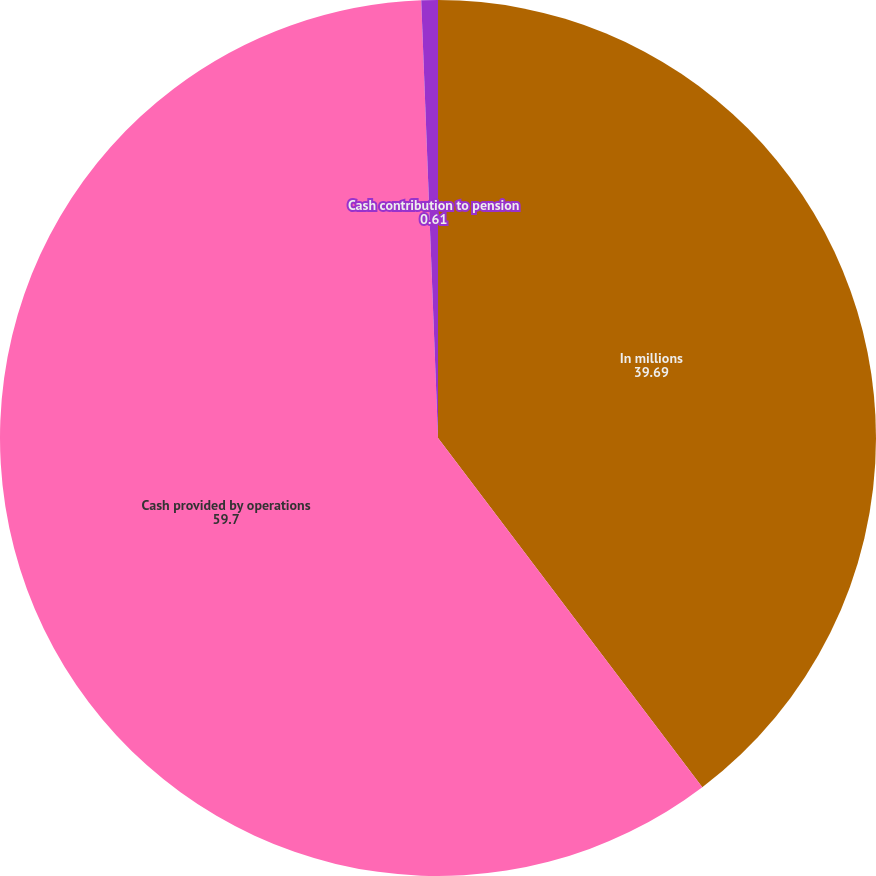Convert chart to OTSL. <chart><loc_0><loc_0><loc_500><loc_500><pie_chart><fcel>In millions<fcel>Cash provided by operations<fcel>Cash contribution to pension<nl><fcel>39.69%<fcel>59.7%<fcel>0.61%<nl></chart> 